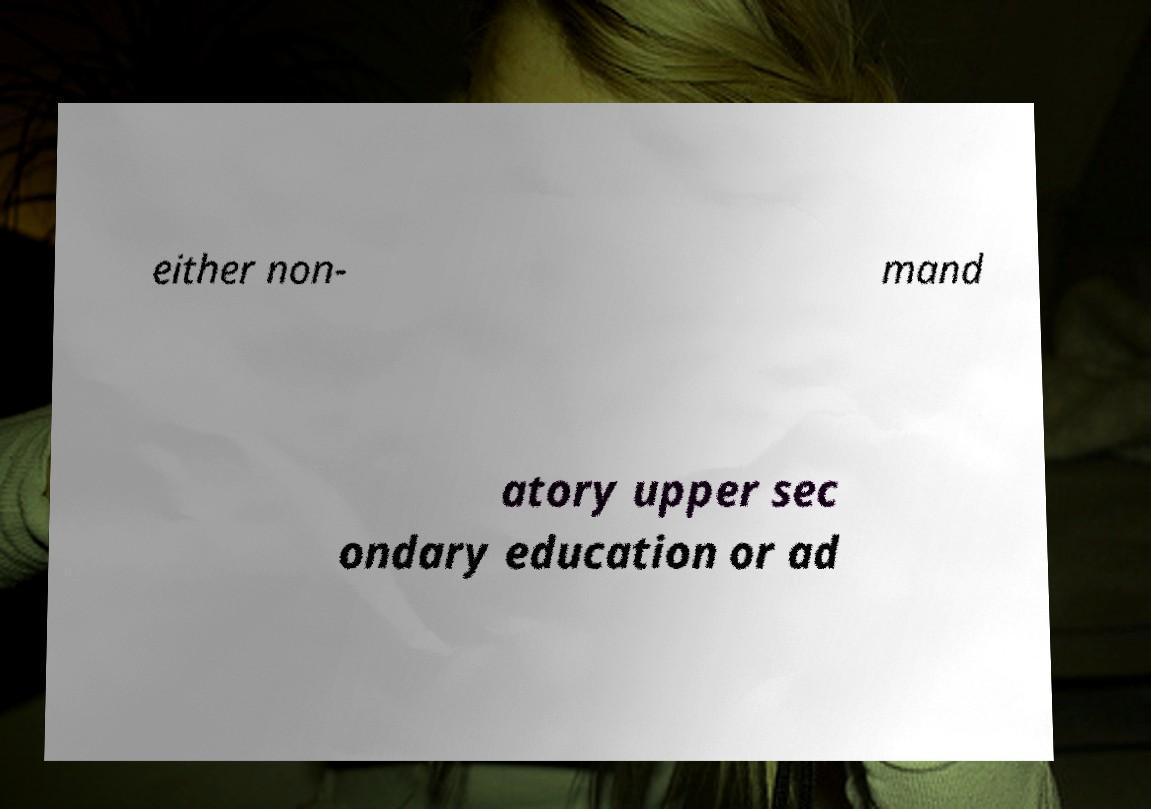There's text embedded in this image that I need extracted. Can you transcribe it verbatim? either non- mand atory upper sec ondary education or ad 